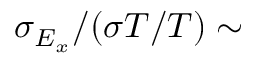Convert formula to latex. <formula><loc_0><loc_0><loc_500><loc_500>\sigma _ { E _ { x } } / ( \sigma T / T ) \sim</formula> 